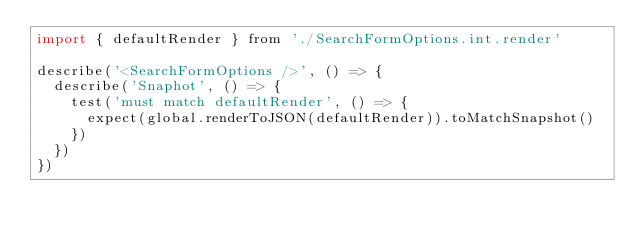<code> <loc_0><loc_0><loc_500><loc_500><_JavaScript_>import { defaultRender } from './SearchFormOptions.int.render'

describe('<SearchFormOptions />', () => {
  describe('Snaphot', () => {
    test('must match defaultRender', () => {
      expect(global.renderToJSON(defaultRender)).toMatchSnapshot()
    })
  })
})
</code> 